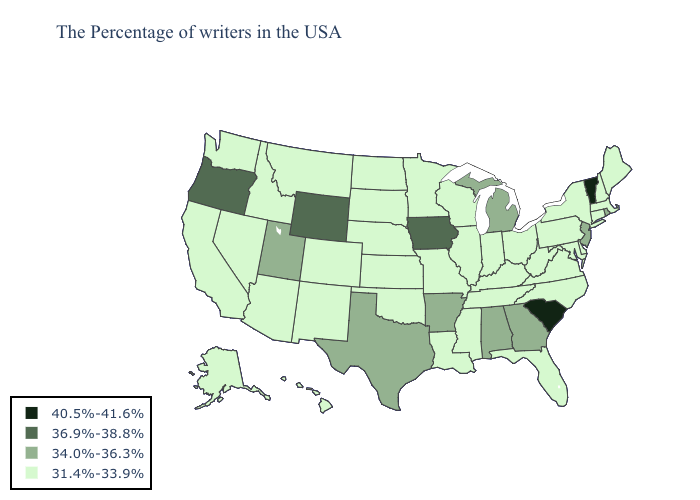Among the states that border South Dakota , which have the lowest value?
Quick response, please. Minnesota, Nebraska, North Dakota, Montana. Does Vermont have the highest value in the USA?
Answer briefly. Yes. Does Wyoming have a higher value than Oregon?
Concise answer only. No. Does the map have missing data?
Answer briefly. No. Name the states that have a value in the range 40.5%-41.6%?
Keep it brief. Vermont, South Carolina. Does Michigan have the lowest value in the USA?
Answer briefly. No. What is the highest value in states that border Arizona?
Quick response, please. 34.0%-36.3%. Does Kansas have the highest value in the USA?
Write a very short answer. No. Which states have the highest value in the USA?
Be succinct. Vermont, South Carolina. What is the value of Alaska?
Be succinct. 31.4%-33.9%. Is the legend a continuous bar?
Concise answer only. No. Name the states that have a value in the range 40.5%-41.6%?
Write a very short answer. Vermont, South Carolina. What is the highest value in the Northeast ?
Give a very brief answer. 40.5%-41.6%. Which states have the highest value in the USA?
Short answer required. Vermont, South Carolina. What is the value of Maryland?
Answer briefly. 31.4%-33.9%. 